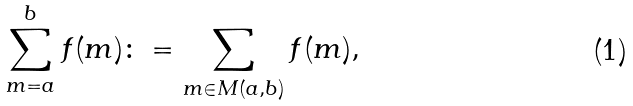Convert formula to latex. <formula><loc_0><loc_0><loc_500><loc_500>\sum _ { m = a } ^ { b } f ( m ) \colon = \sum _ { m \in M ( a , b ) } f ( m ) ,</formula> 